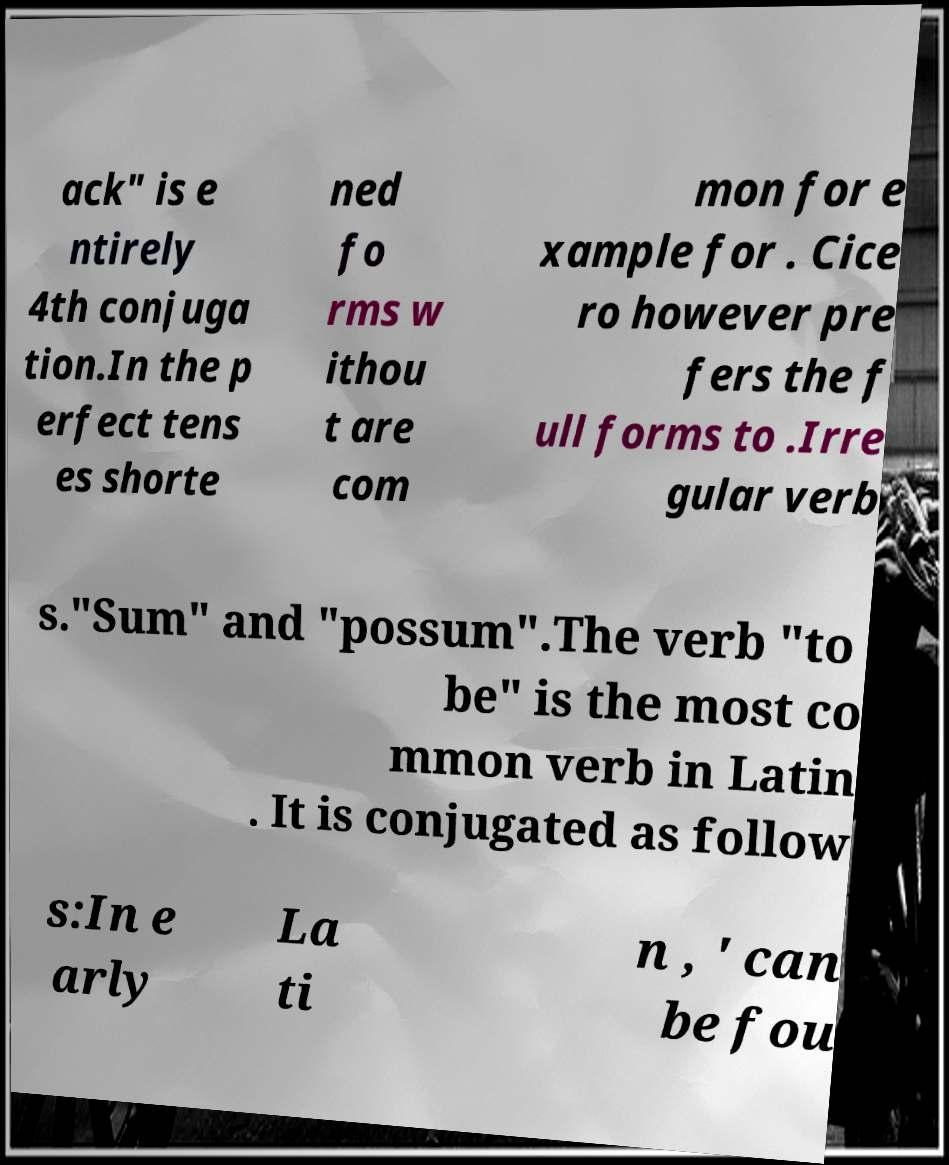Please read and relay the text visible in this image. What does it say? ack" is e ntirely 4th conjuga tion.In the p erfect tens es shorte ned fo rms w ithou t are com mon for e xample for . Cice ro however pre fers the f ull forms to .Irre gular verb s."Sum" and "possum".The verb "to be" is the most co mmon verb in Latin . It is conjugated as follow s:In e arly La ti n , ' can be fou 